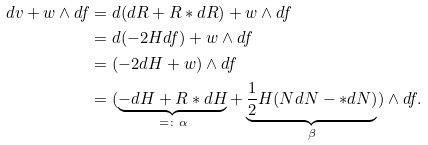<formula> <loc_0><loc_0><loc_500><loc_500>d v + w \wedge d f & = d ( d R + R * d R ) + w \wedge d f \\ & = d ( - 2 H d f ) + w \wedge d f \\ & = ( - 2 d H + w ) \wedge d f \\ & = ( \underbrace { - d H + R * d H } _ { = \colon \alpha } + \underbrace { \frac { 1 } { 2 } H ( N d N - * d N ) } _ { \beta } ) \wedge d f .</formula> 